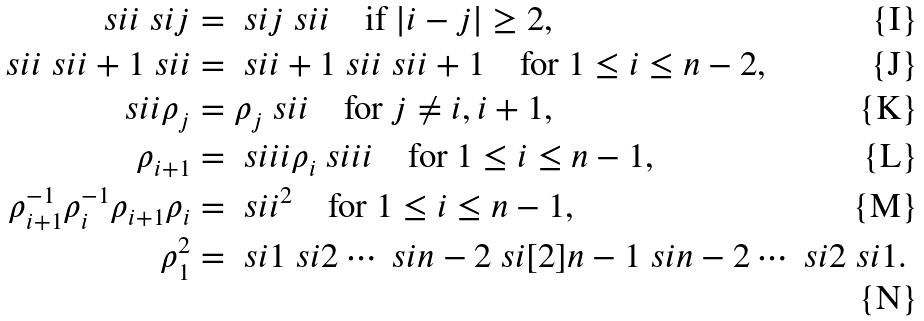Convert formula to latex. <formula><loc_0><loc_0><loc_500><loc_500>\ s i { i } \ s i { j } & = \ s i { j } \ s i { i } \quad \text {if $| i-j|\geq 2$,} \\ \ s i { i } \ s i { i + 1 } \ s i { i } & = \ s i { i + 1 } \ s i { i } \ s i { i + 1 } \quad \text {for $1\leq i\leq n-2$,} \\ \ s i { i } \rho _ { j } & = \rho _ { j } \ s i { i } \quad \text {for $j\neq i,i+1$,} \\ \rho _ { i + 1 } & = \ s i i { i } \rho _ { i } \ s i i { i } \quad \text {for $1\leq i\leq n-1$,} \\ \rho _ { i + 1 } ^ { - 1 } \rho _ { i } ^ { - 1 } \rho _ { i + 1 } \rho _ { i } & = { \ s i { i } } ^ { 2 } \quad \text {for $1\leq i\leq n-1$,} \\ \rho _ { 1 } ^ { 2 } & = \ s i { 1 } \ s i { 2 } \cdots \ s i { n - 2 } \ s i [ 2 ] { n - 1 } \ s i { n - 2 } \cdots \ s i { 2 } \ s i { 1 } .</formula> 